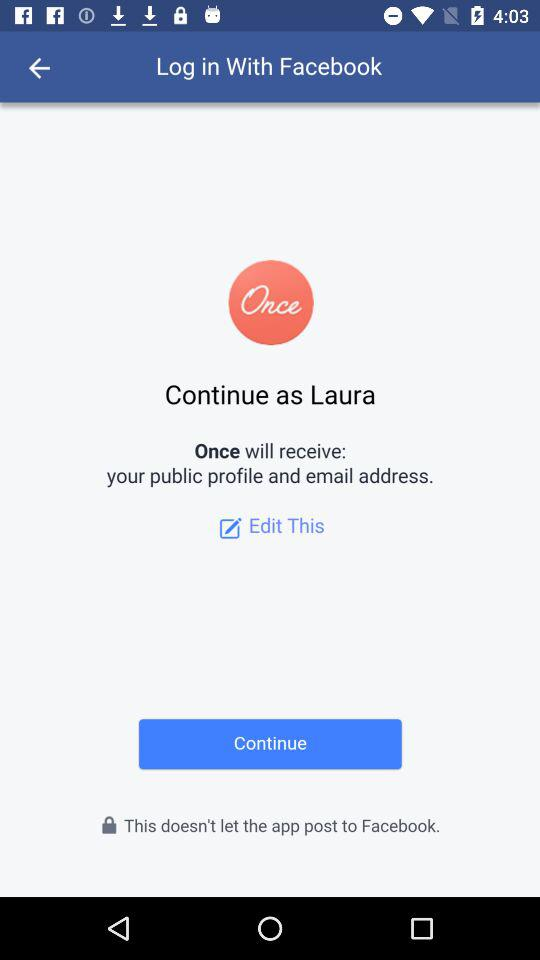What is the login name? The login name is Laura. 